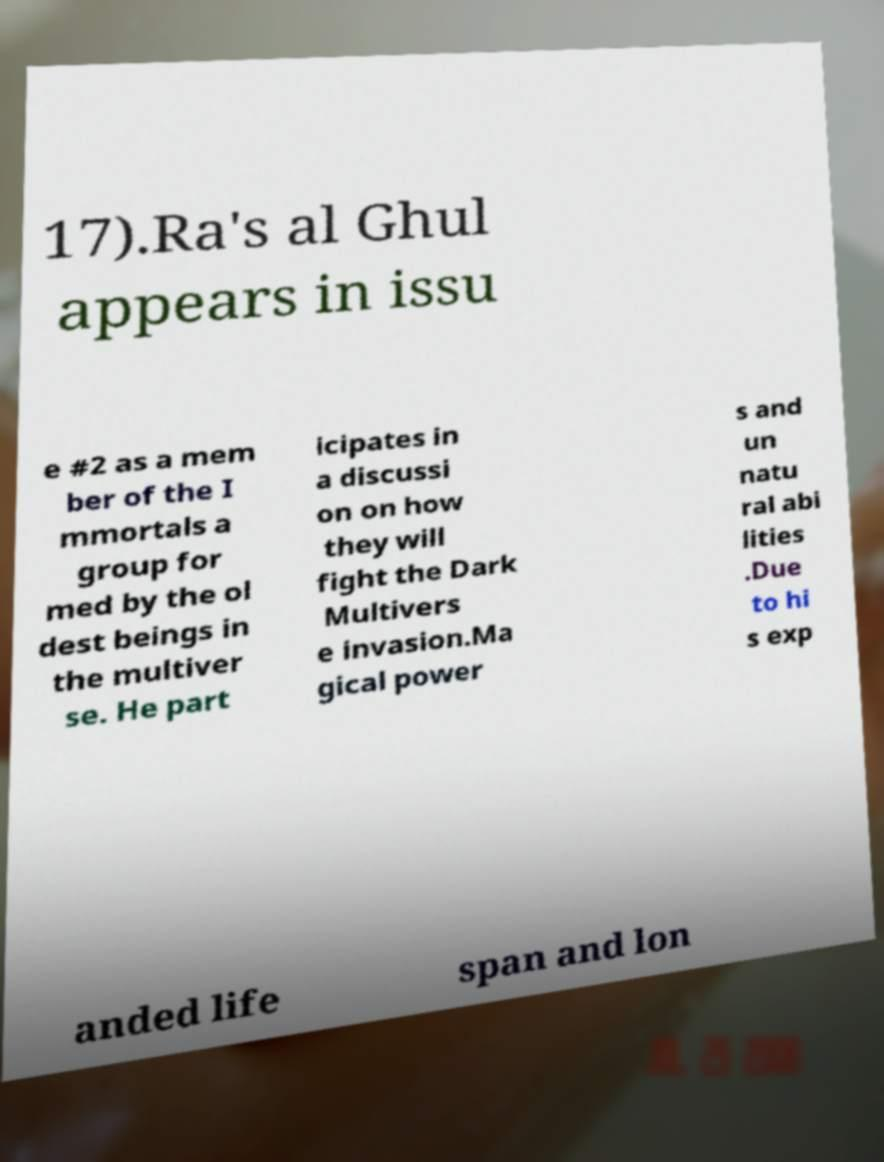Can you accurately transcribe the text from the provided image for me? 17).Ra's al Ghul appears in issu e #2 as a mem ber of the I mmortals a group for med by the ol dest beings in the multiver se. He part icipates in a discussi on on how they will fight the Dark Multivers e invasion.Ma gical power s and un natu ral abi lities .Due to hi s exp anded life span and lon 